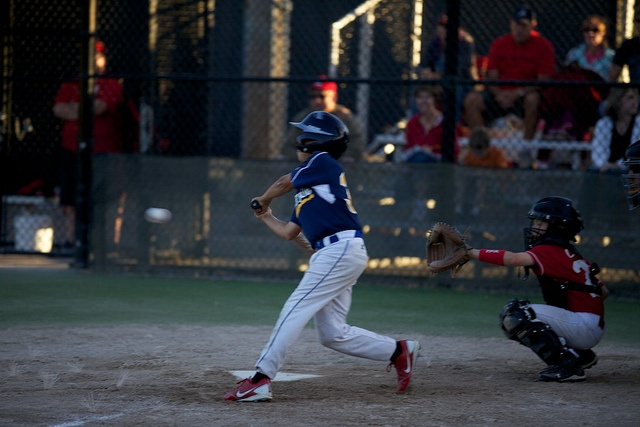Describe the objects in this image and their specific colors. I can see people in black, darkgray, and gray tones, people in black, gray, and maroon tones, people in black, maroon, and brown tones, people in black, maroon, brown, and tan tones, and people in black, gray, blue, and navy tones in this image. 